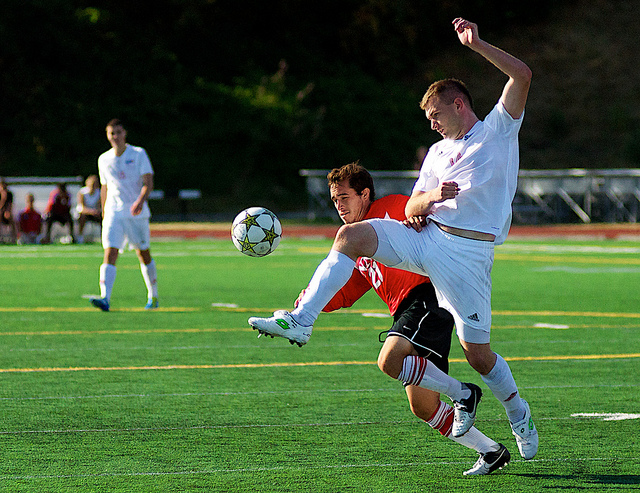Identify and read out the text in this image. 21 